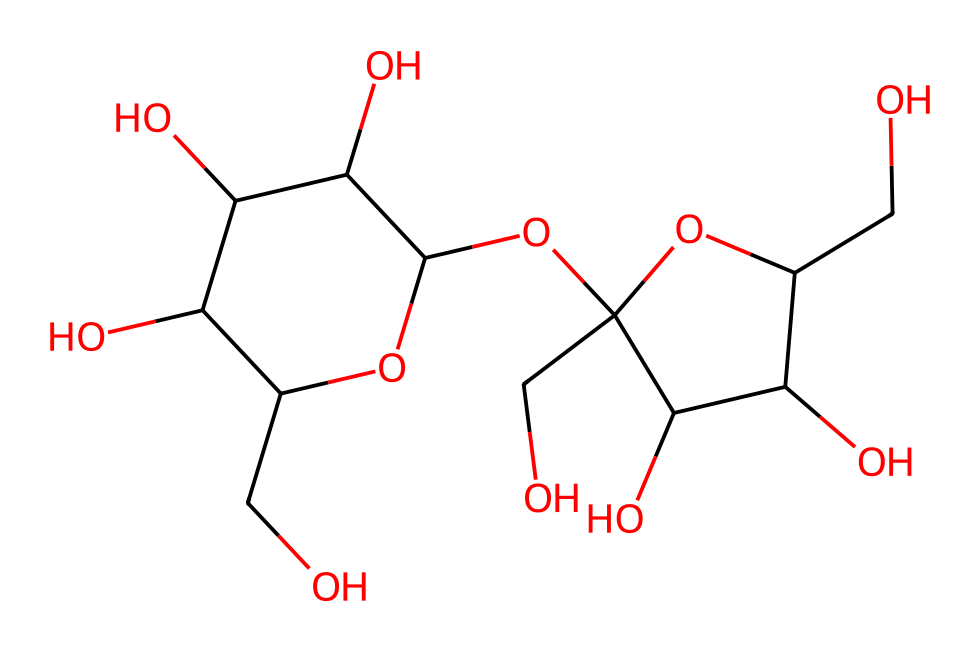What is the molecular formula of sucrose? To find the molecular formula, we count the carbon (C), hydrogen (H), and oxygen (O) atoms in the structure. In sucrose, there are 12 carbon atoms, 22 hydrogen atoms, and 11 oxygen atoms. Therefore, the molecular formula is C12H22O11.
Answer: C12H22O11 How many rings are present in the sucrose structure? Sucrose consists of two sugar units (glucose and fructose) that are cyclic. From the SMILES, we can see that there are two ring structures (indicated by the numbers in the SMILES), one for glucose and one for fructose.
Answer: 2 What kind of carbohydrate is sucrose classified as? Sucrose is known as a disaccharide since it is composed of two monosaccharide units (glucose and fructose). This classification is based on its structure, having two sugar molecules joined together.
Answer: disaccharide What type of glycosidic bond is present in sucrose? The bond between the glucose and fructose units in sucrose is an alpha-1,2-glycosidic bond. This can be identified by analyzing the way the two sugar units are linked together in the structure.
Answer: alpha-1,2-glycosidic What is the role of sucrose in the tea? In traditional British tea, sucrose acts as a sweetener, enhancing the flavor and making the tea more enjoyable. This role is based on sucrose’s property of being sweet and palatable.
Answer: sweetener How many oxygen atoms are in the sucrose structure? Counting the oxygen atoms in the SMILES representation reveals there are 11 oxygen atoms in the structure of sucrose. The total is derived from examining each segment of the SMILES that represents the sugar and its linkages.
Answer: 11 